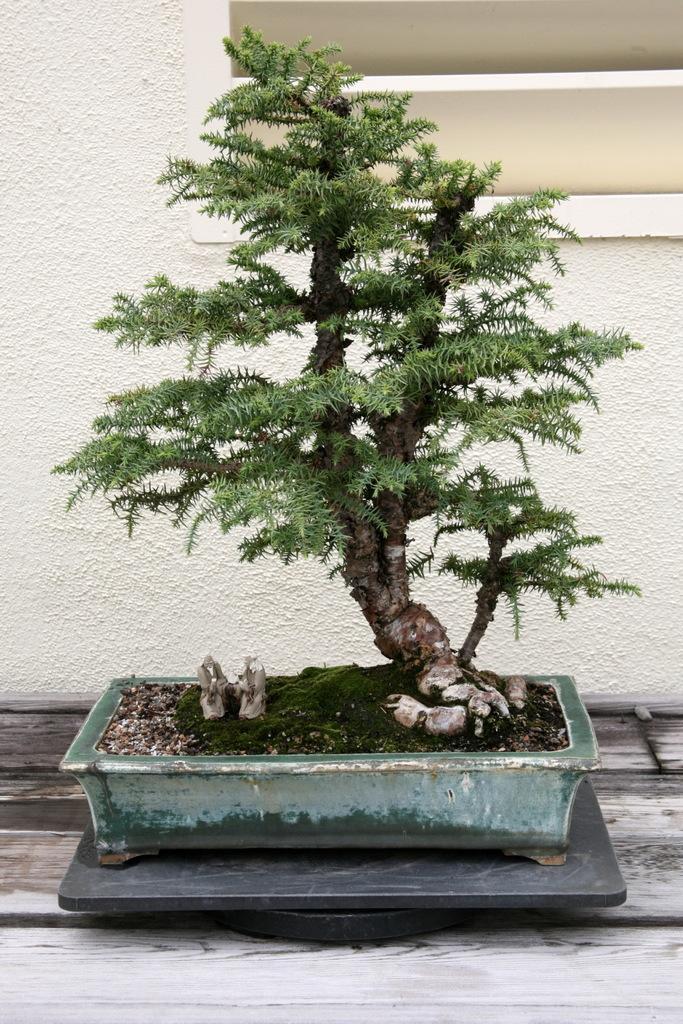Please provide a concise description of this image. In this image, we can see a bonsai plant with pot. Here we can see black marbles and wooden surface. Background we can see the white wall. 